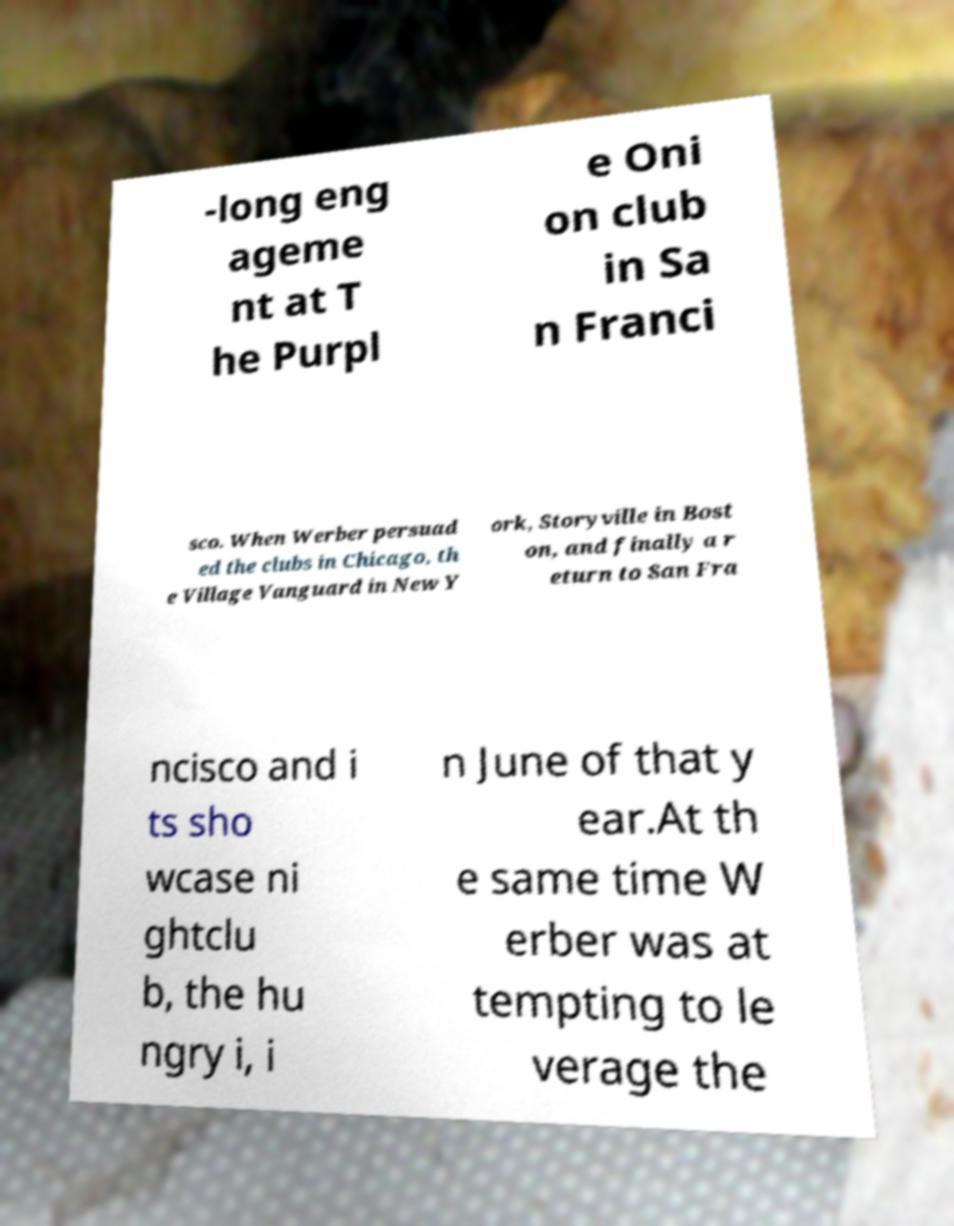Could you assist in decoding the text presented in this image and type it out clearly? -long eng ageme nt at T he Purpl e Oni on club in Sa n Franci sco. When Werber persuad ed the clubs in Chicago, th e Village Vanguard in New Y ork, Storyville in Bost on, and finally a r eturn to San Fra ncisco and i ts sho wcase ni ghtclu b, the hu ngry i, i n June of that y ear.At th e same time W erber was at tempting to le verage the 